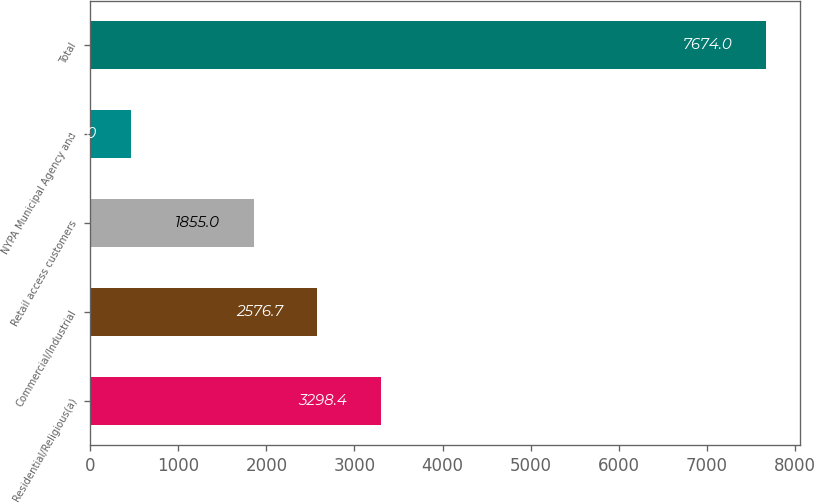<chart> <loc_0><loc_0><loc_500><loc_500><bar_chart><fcel>Residential/Religious(a)<fcel>Commercial/Industrial<fcel>Retail access customers<fcel>NYPA Municipal Agency and<fcel>Total<nl><fcel>3298.4<fcel>2576.7<fcel>1855<fcel>457<fcel>7674<nl></chart> 